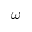<formula> <loc_0><loc_0><loc_500><loc_500>\omega</formula> 